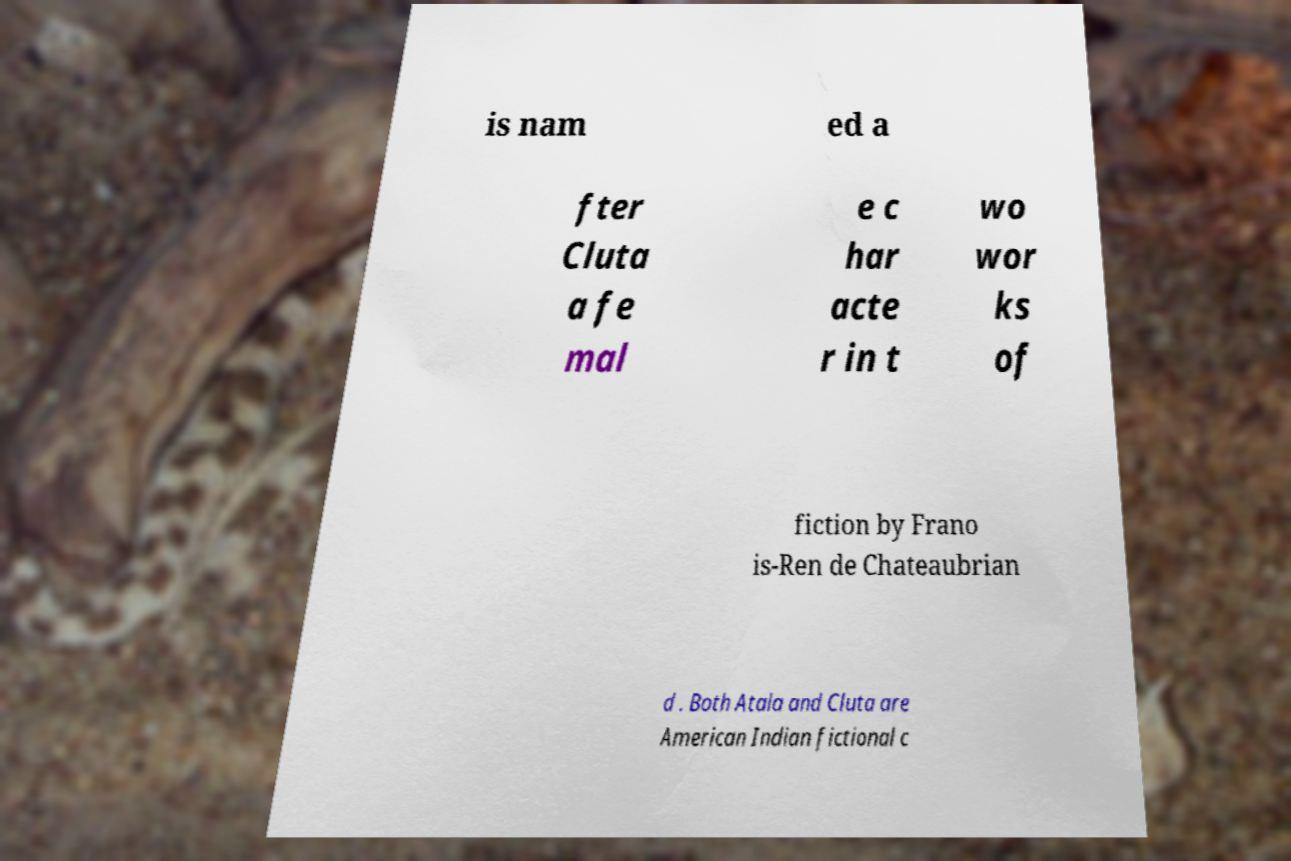Can you read and provide the text displayed in the image?This photo seems to have some interesting text. Can you extract and type it out for me? is nam ed a fter Cluta a fe mal e c har acte r in t wo wor ks of fiction by Frano is-Ren de Chateaubrian d . Both Atala and Cluta are American Indian fictional c 